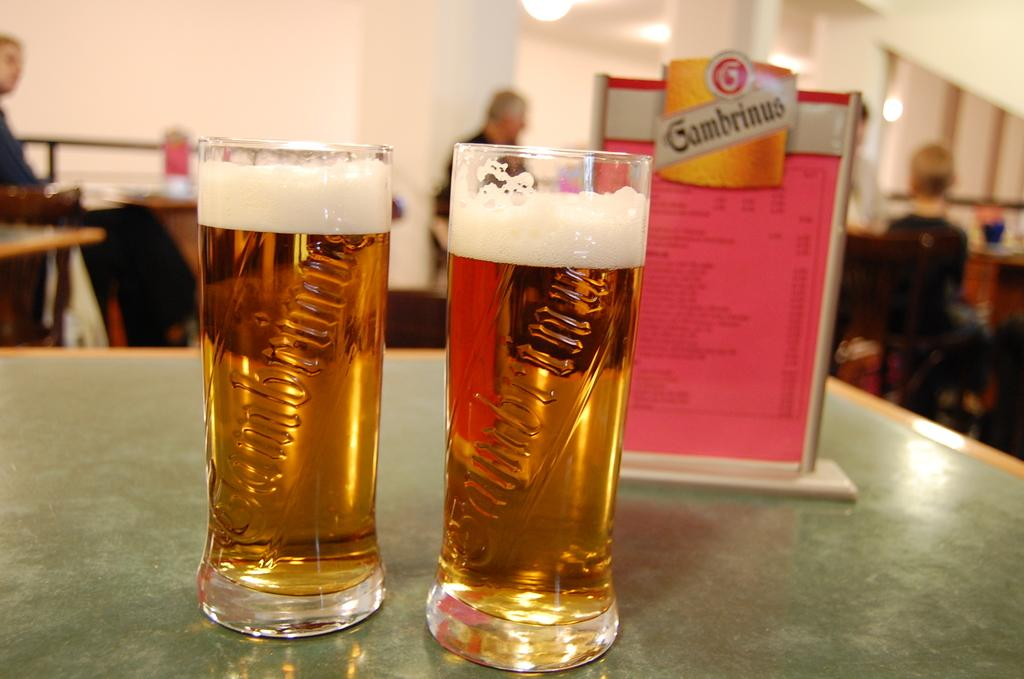<image>
Relay a brief, clear account of the picture shown. Two nearly full pints of Gabmrinus beer sit on a table. 